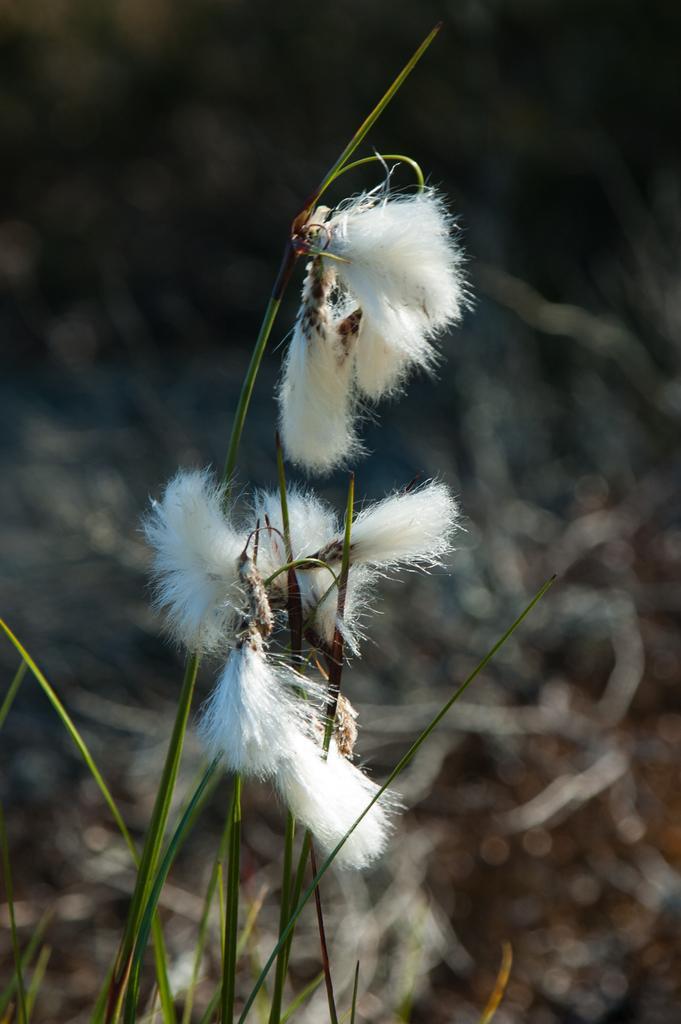Please provide a concise description of this image. In the image I can see a plant to which there are some flowers which are in white color. 